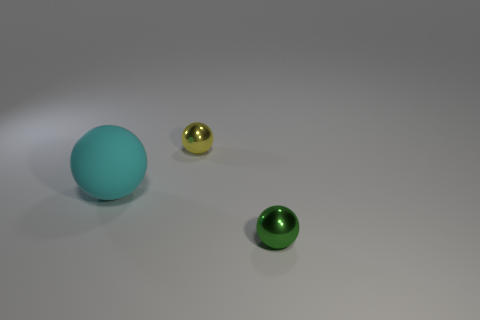Are there any other things that are the same material as the big thing?
Ensure brevity in your answer.  No. There is a metal object in front of the cyan matte sphere; does it have the same size as the yellow shiny thing?
Keep it short and to the point. Yes. There is a metallic thing that is in front of the yellow object; is its shape the same as the cyan thing?
Your response must be concise. Yes. How many objects are small yellow spheres or objects that are to the left of the green shiny sphere?
Keep it short and to the point. 2. Is the number of small yellow metallic blocks less than the number of tiny green metallic things?
Keep it short and to the point. Yes. Are there more large rubber things than tiny things?
Provide a succinct answer. No. How many other objects are there of the same material as the yellow thing?
Make the answer very short. 1. How many objects are in front of the metal ball left of the metallic sphere in front of the large matte object?
Give a very brief answer. 2. How many metallic things are tiny purple objects or big things?
Make the answer very short. 0. How big is the shiny ball that is on the left side of the metal ball that is in front of the big cyan ball?
Give a very brief answer. Small. 